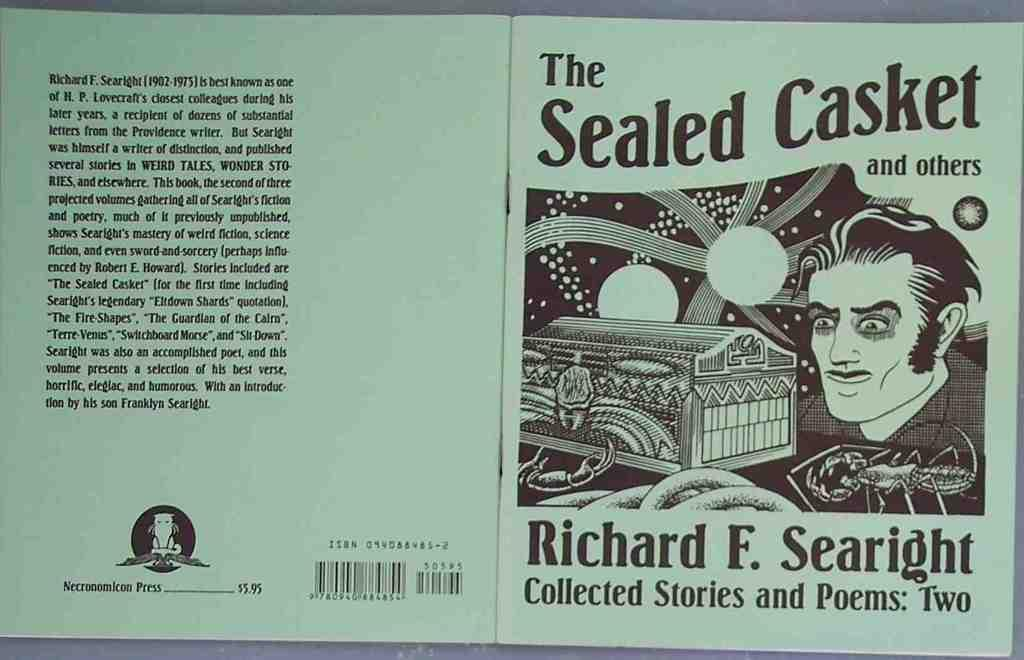<image>
Provide a brief description of the given image. A collection of stories by Richard F. Searight 